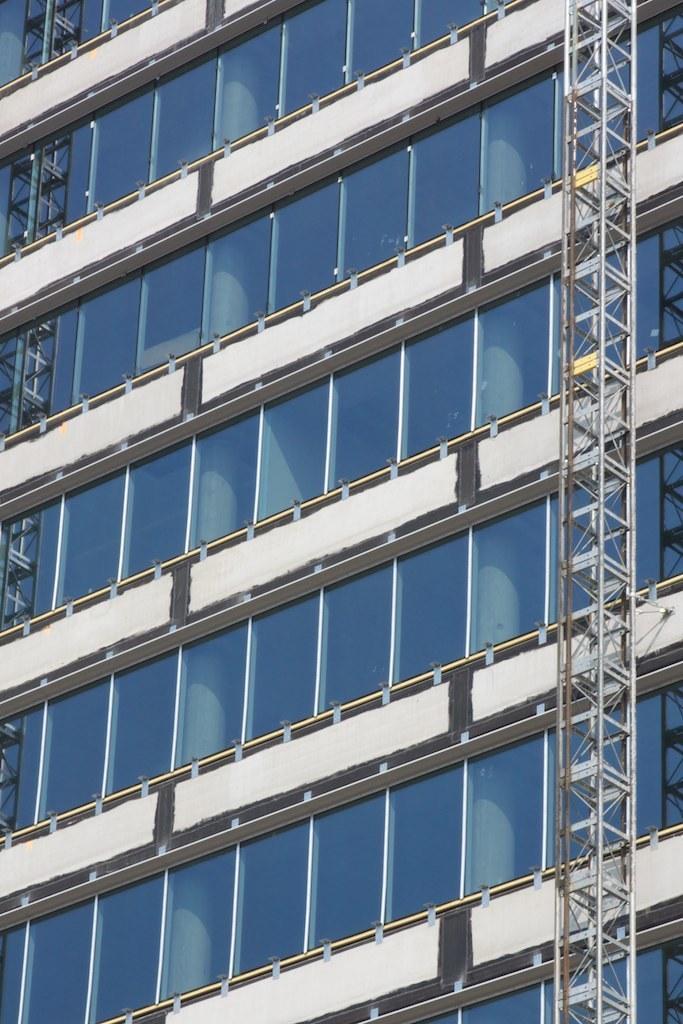Please provide a concise description of this image. In the image there is a building with glasses and walls. On the right corner of the image there is a tower stand. 